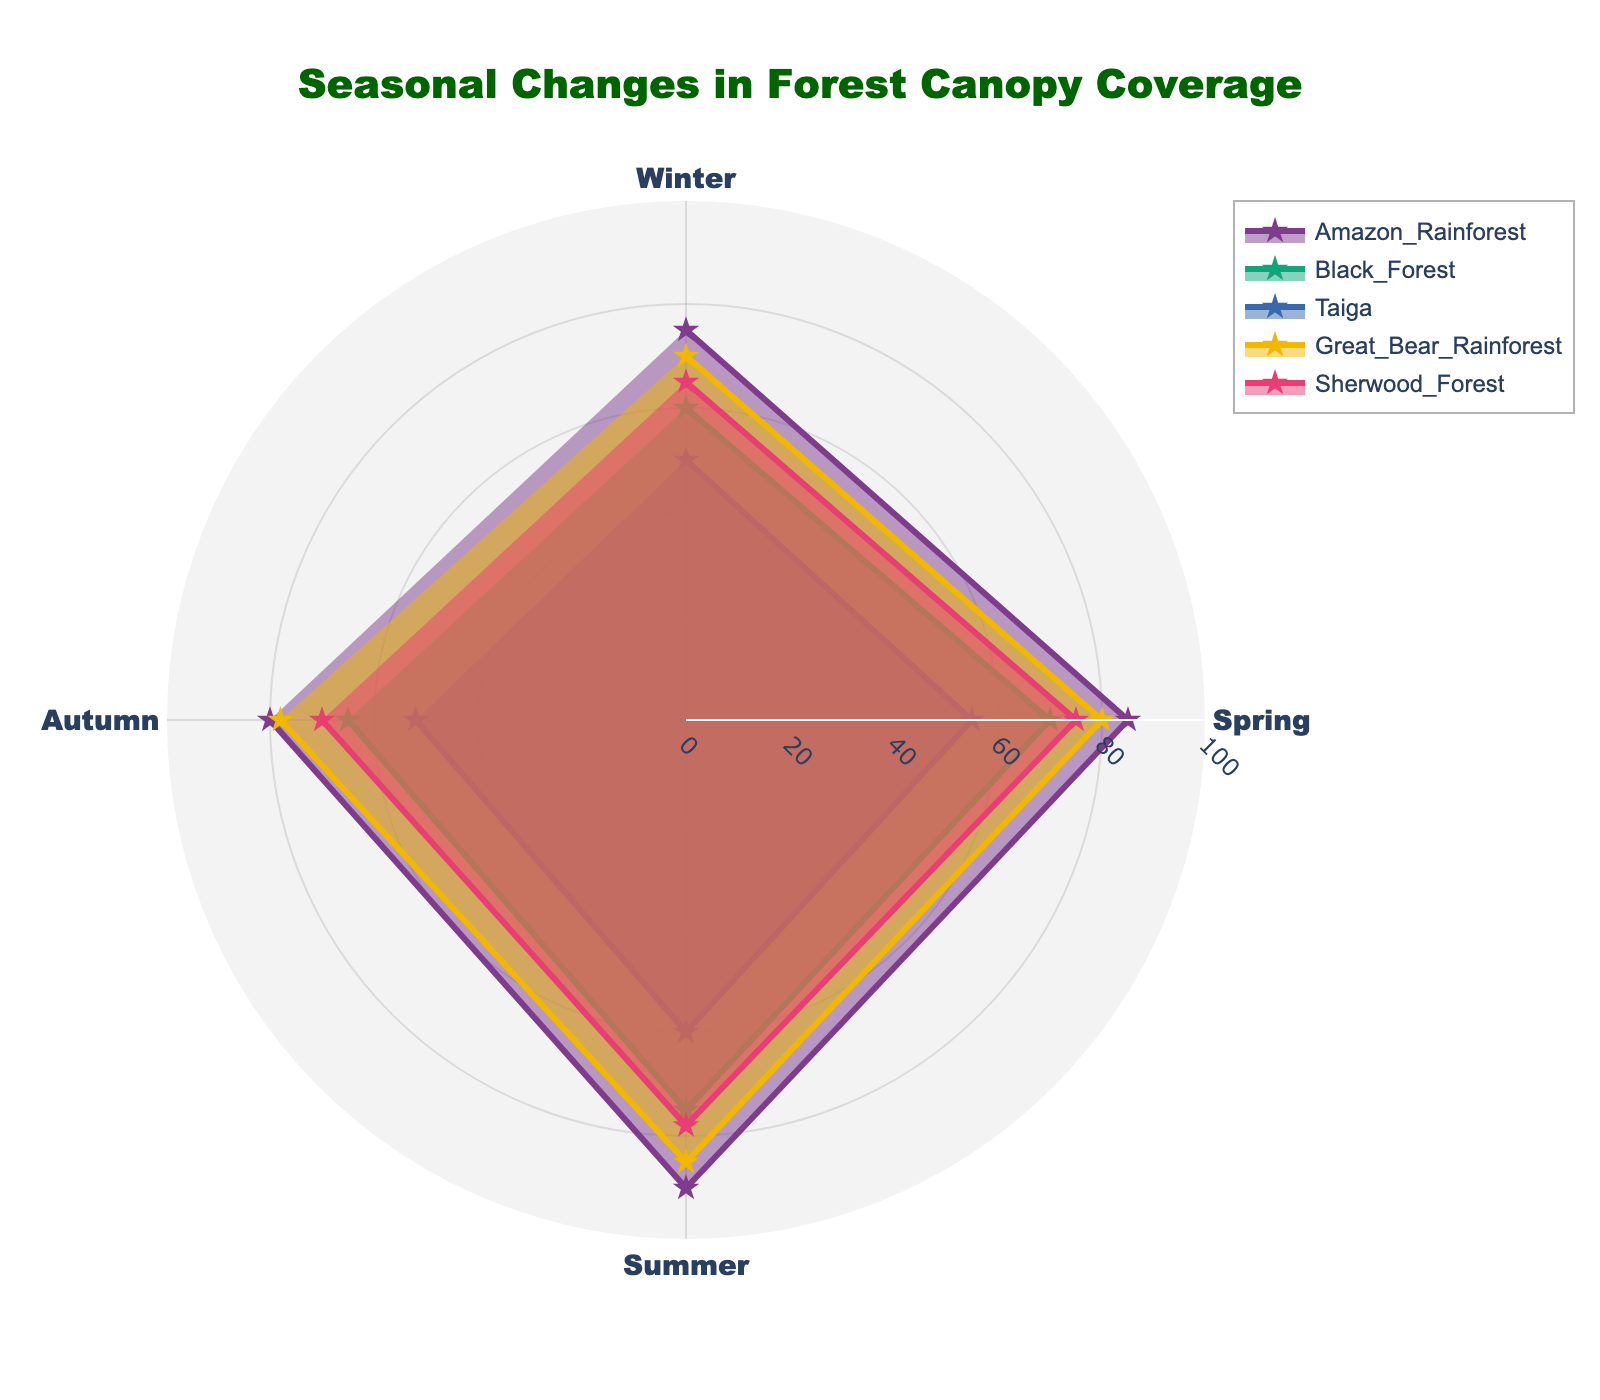What's the title of the figure? The title is located at the top of the figure, and it helps to understand the overall theme and subject of the plot. The figure shows "Seasonal Changes in Forest Canopy Coverage".
Answer: Seasonal Changes in Forest Canopy Coverage What are the seasons represented in the figure? The seasons can be observed from the angular axis. In this figure, the seasons include Winter, Spring, Summer, and Autumn.
Answer: Winter, Spring, Summer, Autumn Which forest location has the highest canopy coverage during the Summer? By observing the data points for the Summer season, we can see the radial distances of all locations' canopy coverage. The Amazon Rainforest has the canopy coverage at 90%, which is the highest among all the locations.
Answer: Amazon Rainforest What is the average canopy coverage in the Sherwood Forest across all seasons? To find the average canopy coverage, sum the values for Sherwood Forest across all seasons (Winter: 65%, Spring: 75%, Summer: 78%, Autumn: 70%) and then divide by the number of seasons (4). (65 + 75 + 78 + 70)/4 = 72%
Answer: 72% Which location shows the greatest seasonal variation in canopy coverage? Seasonal variation can be determined by the difference between the highest and lowest canopy coverage values for each location. For the Amazon Rainforest (90%-75%=15%), Black Forest (75%-60%=15%), Taiga (60%-50%=10%), Great Bear Rainforest (85%-70%=15%), Sherwood Forest (78%-65%=13%). All Amazon Rainforest, Black Forest, and Great Bear Rainforest have the highest variation of 15%.
Answer: Amazon Rainforest, Black Forest, Great Bear Rainforest In which season does the Taiga have its highest canopy coverage, and what is the value? A simple glance at the data points for Taiga reveals that the greatest value for canopy coverage occurs during the Summer, reaching 60%.
Answer: Summer, 60% How does the Winter canopy coverage in the Black Forest compare to the Autumn canopy coverage in the Taiga? From the radial distance for Winter in Black Forest (60%) and Autumn in Taiga (52%), we see that the Black Forest during Winter has higher canopy coverage than the Taiga during Autumn.
Answer: Black Forest during Winter has higher coverage Which forest has the least coverage in the Spring season, and what is the value? By examining the coverage values in the Spring for all locations, we can identify that the Taiga has the lowest canopy coverage at 55%.
Answer: Taiga, 55% What's the total canopy coverage across all seasons for the Great Bear Rainforest? Summing up the values for each season for the Great Bear Rainforest (Winter: 70%, Spring: 80%, Summer: 85%, Autumn: 78%) gives the total coverage. 70 + 80 + 85 + 78 = 313%
Answer: 313% 